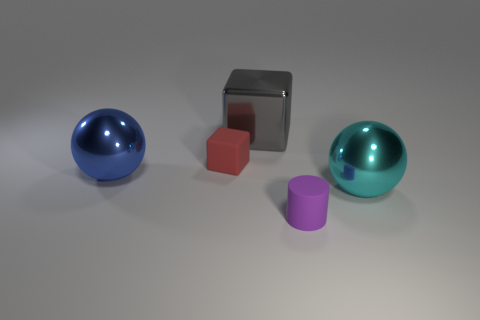Add 1 small blocks. How many objects exist? 6 Subtract 1 blocks. How many blocks are left? 1 Subtract all blue spheres. How many spheres are left? 1 Subtract all cylinders. How many objects are left? 4 Subtract all blue cubes. How many cyan spheres are left? 1 Add 5 red matte things. How many red matte things exist? 6 Subtract 0 yellow spheres. How many objects are left? 5 Subtract all gray spheres. Subtract all green cylinders. How many spheres are left? 2 Subtract all rubber cylinders. Subtract all blocks. How many objects are left? 2 Add 3 large gray blocks. How many large gray blocks are left? 4 